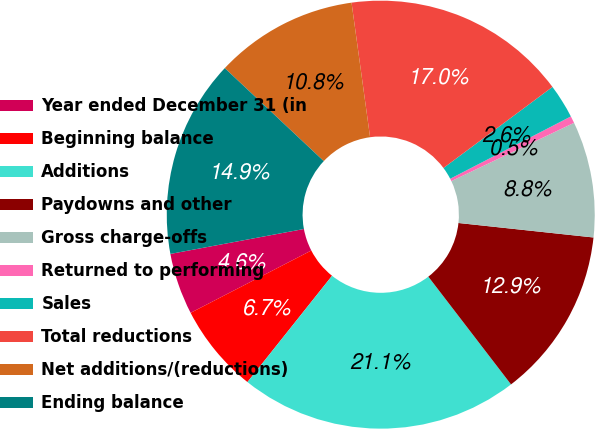Convert chart to OTSL. <chart><loc_0><loc_0><loc_500><loc_500><pie_chart><fcel>Year ended December 31 (in<fcel>Beginning balance<fcel>Additions<fcel>Paydowns and other<fcel>Gross charge-offs<fcel>Returned to performing<fcel>Sales<fcel>Total reductions<fcel>Net additions/(reductions)<fcel>Ending balance<nl><fcel>4.65%<fcel>6.71%<fcel>21.12%<fcel>12.88%<fcel>8.76%<fcel>0.53%<fcel>2.59%<fcel>17.0%<fcel>10.82%<fcel>14.94%<nl></chart> 